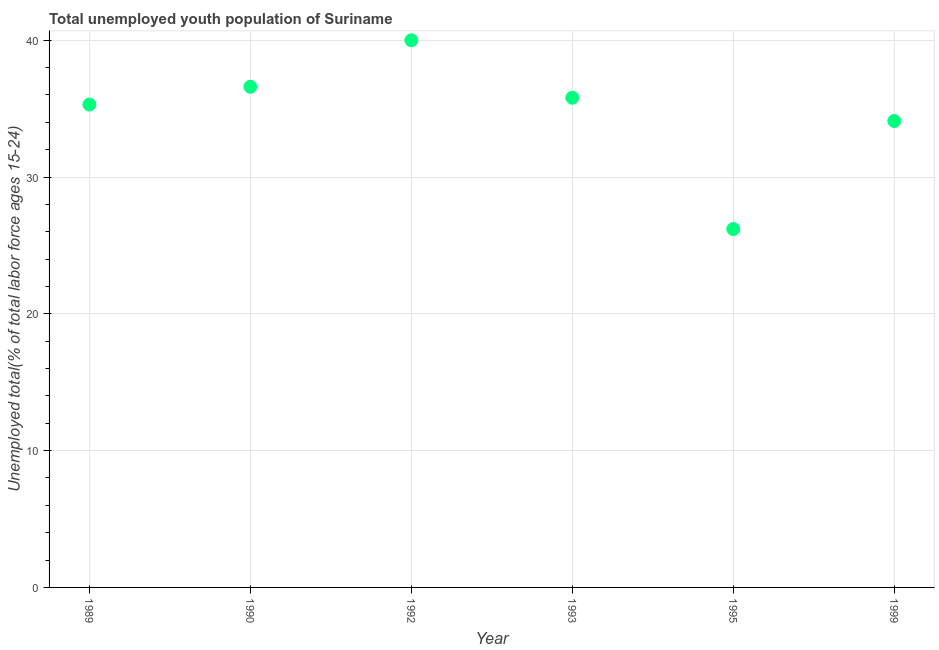What is the unemployed youth in 1993?
Your answer should be very brief. 35.8. Across all years, what is the maximum unemployed youth?
Offer a very short reply. 40. Across all years, what is the minimum unemployed youth?
Make the answer very short. 26.2. In which year was the unemployed youth minimum?
Provide a succinct answer. 1995. What is the sum of the unemployed youth?
Offer a terse response. 208. What is the difference between the unemployed youth in 1990 and 1993?
Your answer should be compact. 0.8. What is the average unemployed youth per year?
Your response must be concise. 34.67. What is the median unemployed youth?
Offer a very short reply. 35.55. What is the ratio of the unemployed youth in 1990 to that in 1993?
Provide a short and direct response. 1.02. What is the difference between the highest and the second highest unemployed youth?
Your answer should be compact. 3.4. Is the sum of the unemployed youth in 1993 and 1995 greater than the maximum unemployed youth across all years?
Offer a terse response. Yes. What is the difference between the highest and the lowest unemployed youth?
Ensure brevity in your answer.  13.8. In how many years, is the unemployed youth greater than the average unemployed youth taken over all years?
Your answer should be compact. 4. Does the unemployed youth monotonically increase over the years?
Offer a terse response. No. How many dotlines are there?
Ensure brevity in your answer.  1. What is the difference between two consecutive major ticks on the Y-axis?
Your answer should be very brief. 10. Does the graph contain any zero values?
Make the answer very short. No. What is the title of the graph?
Provide a succinct answer. Total unemployed youth population of Suriname. What is the label or title of the X-axis?
Make the answer very short. Year. What is the label or title of the Y-axis?
Offer a very short reply. Unemployed total(% of total labor force ages 15-24). What is the Unemployed total(% of total labor force ages 15-24) in 1989?
Make the answer very short. 35.3. What is the Unemployed total(% of total labor force ages 15-24) in 1990?
Keep it short and to the point. 36.6. What is the Unemployed total(% of total labor force ages 15-24) in 1992?
Offer a terse response. 40. What is the Unemployed total(% of total labor force ages 15-24) in 1993?
Make the answer very short. 35.8. What is the Unemployed total(% of total labor force ages 15-24) in 1995?
Ensure brevity in your answer.  26.2. What is the Unemployed total(% of total labor force ages 15-24) in 1999?
Your answer should be compact. 34.1. What is the difference between the Unemployed total(% of total labor force ages 15-24) in 1989 and 1995?
Offer a very short reply. 9.1. What is the difference between the Unemployed total(% of total labor force ages 15-24) in 1990 and 1992?
Make the answer very short. -3.4. What is the difference between the Unemployed total(% of total labor force ages 15-24) in 1990 and 1993?
Keep it short and to the point. 0.8. What is the difference between the Unemployed total(% of total labor force ages 15-24) in 1990 and 1999?
Your answer should be compact. 2.5. What is the difference between the Unemployed total(% of total labor force ages 15-24) in 1992 and 1993?
Provide a succinct answer. 4.2. What is the difference between the Unemployed total(% of total labor force ages 15-24) in 1993 and 1995?
Give a very brief answer. 9.6. What is the ratio of the Unemployed total(% of total labor force ages 15-24) in 1989 to that in 1990?
Provide a succinct answer. 0.96. What is the ratio of the Unemployed total(% of total labor force ages 15-24) in 1989 to that in 1992?
Your answer should be compact. 0.88. What is the ratio of the Unemployed total(% of total labor force ages 15-24) in 1989 to that in 1993?
Provide a short and direct response. 0.99. What is the ratio of the Unemployed total(% of total labor force ages 15-24) in 1989 to that in 1995?
Make the answer very short. 1.35. What is the ratio of the Unemployed total(% of total labor force ages 15-24) in 1989 to that in 1999?
Make the answer very short. 1.03. What is the ratio of the Unemployed total(% of total labor force ages 15-24) in 1990 to that in 1992?
Provide a succinct answer. 0.92. What is the ratio of the Unemployed total(% of total labor force ages 15-24) in 1990 to that in 1995?
Keep it short and to the point. 1.4. What is the ratio of the Unemployed total(% of total labor force ages 15-24) in 1990 to that in 1999?
Give a very brief answer. 1.07. What is the ratio of the Unemployed total(% of total labor force ages 15-24) in 1992 to that in 1993?
Your answer should be compact. 1.12. What is the ratio of the Unemployed total(% of total labor force ages 15-24) in 1992 to that in 1995?
Provide a succinct answer. 1.53. What is the ratio of the Unemployed total(% of total labor force ages 15-24) in 1992 to that in 1999?
Your response must be concise. 1.17. What is the ratio of the Unemployed total(% of total labor force ages 15-24) in 1993 to that in 1995?
Make the answer very short. 1.37. What is the ratio of the Unemployed total(% of total labor force ages 15-24) in 1995 to that in 1999?
Your answer should be very brief. 0.77. 